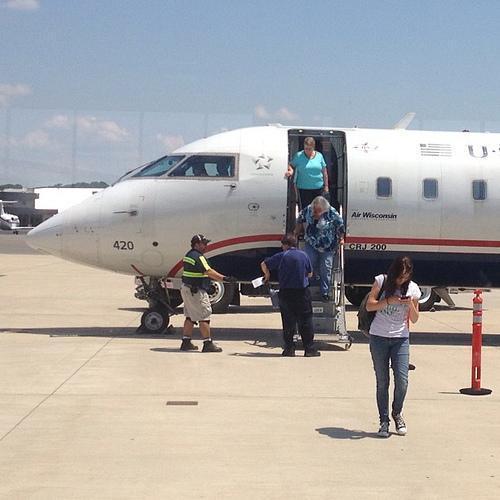How many people do you see?
Give a very brief answer. 5. 